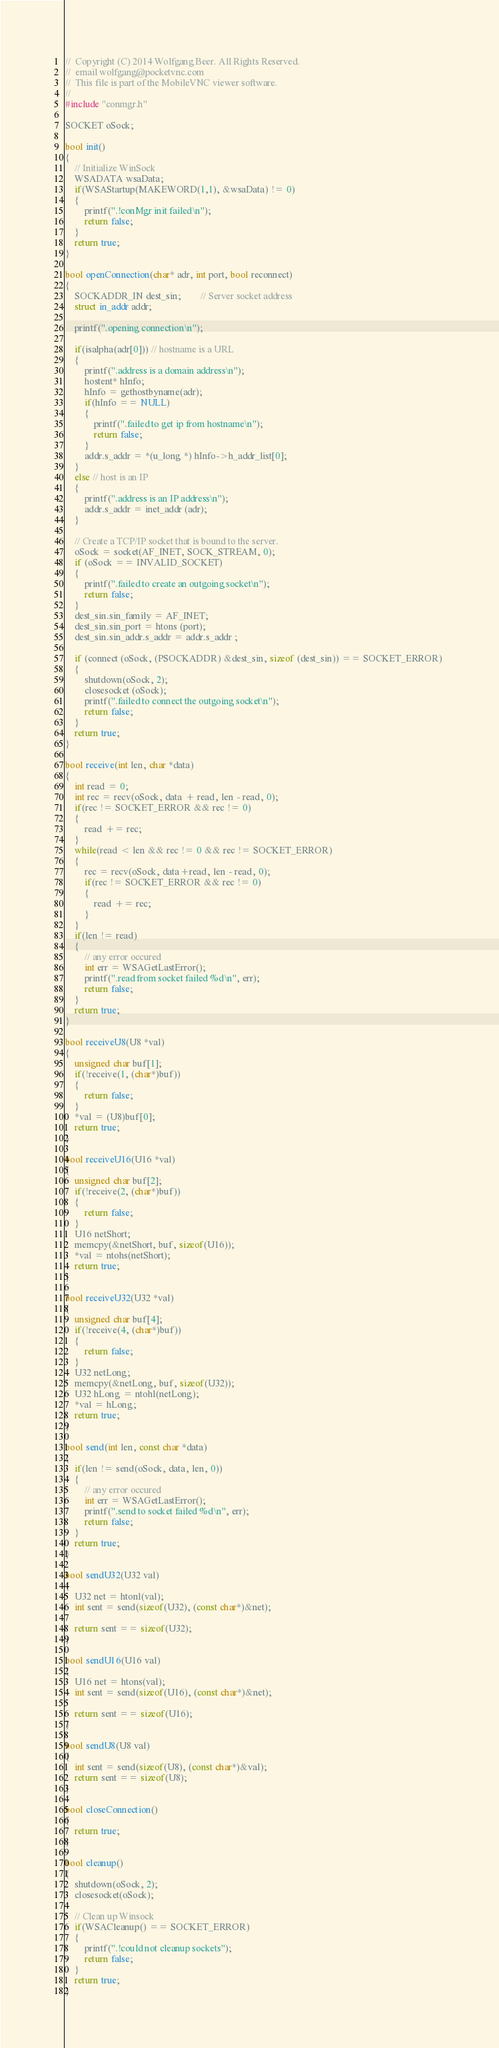<code> <loc_0><loc_0><loc_500><loc_500><_C++_>//  Copyright (C) 2014 Wolfgang Beer. All Rights Reserved.
//  email wolfgang@pocketvnc.com
//  This file is part of the MobileVNC viewer software.
//
#include "conmgr.h"

SOCKET oSock;

bool init() 
{
	// Initialize WinSock
	WSADATA wsaData;
	if(WSAStartup(MAKEWORD(1,1), &wsaData) != 0) 
	{
		printf(".!conMgr init failed\n");
		return false;
	}
	return true;
}

bool openConnection(char* adr, int port, bool reconnect) 
{
	SOCKADDR_IN dest_sin;        // Server socket address
	struct in_addr addr;

	printf(".opening connection\n");
	
	if(isalpha(adr[0])) // hostname is a URL
	{ 
		printf(".address is a domain address\n");
		hostent* hInfo; 
		hInfo = gethostbyname(adr); 
		if(hInfo == NULL)
		{
			printf(".failed to get ip from hostname\n");
			return false;
		}
		addr.s_addr = *(u_long *) hInfo->h_addr_list[0];
	}
	else // host is an IP
	{ 
		printf(".address is an IP address\n");
		addr.s_addr = inet_addr (adr);
	}

	// Create a TCP/IP socket that is bound to the server.
	oSock = socket(AF_INET, SOCK_STREAM, 0);
	if (oSock == INVALID_SOCKET)
	{
		printf(".failed to create an outgoing socket\n");
		return false;
	}
	dest_sin.sin_family = AF_INET;
	dest_sin.sin_port = htons (port);  
	dest_sin.sin_addr.s_addr = addr.s_addr ;
	
	if (connect (oSock, (PSOCKADDR) &dest_sin, sizeof (dest_sin)) == SOCKET_ERROR) 
	{
		shutdown(oSock, 2);
		closesocket (oSock);
		printf(".failed to connect the outgoing socket\n");
		return false;
	}
	return true;
}

bool receive(int len, char *data) 
{
	int read = 0;
	int rec = recv(oSock, data + read, len - read, 0);
	if(rec != SOCKET_ERROR && rec != 0) 
	{
		read += rec;
	}
	while(read < len && rec != 0 && rec != SOCKET_ERROR)
	{
		rec = recv(oSock, data+read, len - read, 0);
		if(rec != SOCKET_ERROR && rec != 0) 
		{
			read += rec;
		}
	}
	if(len != read) 
	{
		// any error occured
		int err = WSAGetLastError();
		printf(".read from socket failed %d\n", err);
		return false;
	}
	return true;
}

bool receiveU8(U8 *val)
{
	unsigned char buf[1];
	if(!receive(1, (char*)buf))
	{
		return false;
	}
	*val = (U8)buf[0];
	return true;
}

bool receiveU16(U16 *val)
{
	unsigned char buf[2];
	if(!receive(2, (char*)buf))
	{
		return false;
	}
	U16 netShort;
	memcpy(&netShort, buf, sizeof(U16));
	*val = ntohs(netShort);
	return true;
}

bool receiveU32(U32 *val)
{
	unsigned char buf[4];
	if(!receive(4, (char*)buf)) 
	{
		return false;
	}
	U32 netLong;
	memcpy(&netLong, buf, sizeof(U32));
	U32 hLong = ntohl(netLong);
	*val = hLong;
	return true;
}

bool send(int len, const char *data)
{
	if(len != send(oSock, data, len, 0)) 
	{
		// any error occured
		int err = WSAGetLastError();
		printf(".send to socket failed %d\n", err);
		return false;
	}
	return true;
}

bool sendU32(U32 val) 
{
	U32 net = htonl(val);
	int sent = send(sizeof(U32), (const char*)&net);

	return sent == sizeof(U32);
}

bool sendU16(U16 val) 
{
	U16 net = htons(val);
	int sent = send(sizeof(U16), (const char*)&net);

	return sent == sizeof(U16);
}

bool sendU8(U8 val) 
{
	int sent = send(sizeof(U8), (const char*)&val);
	return sent == sizeof(U8);
}

bool closeConnection()
{
	return true;
}

bool cleanup() 
{
	shutdown(oSock, 2);
	closesocket(oSock);

	// Clean up Winsock
	if(WSACleanup() == SOCKET_ERROR) 
	{
		printf(".!could not cleanup sockets");
		return false;
	}
	return true;
}</code> 